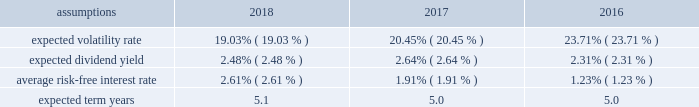Notes to the audited consolidated financial statements director stock compensation subplan eastman's 2018 director stock compensation subplan ( "directors' subplan" ) , a component of the 2017 omnibus plan , remains in effect until terminated by the board of directors or the earlier termination of the 2017 omnibus plan .
The directors' subplan provides for structured awards of restricted shares to non-employee members of the board of directors .
Restricted shares awarded under the directors' subplan are subject to the same terms and conditions of the 2017 omnibus plan .
The directors' subplan does not constitute a separate source of shares for grant of equity awards and all shares awarded are part of the 10 million shares authorized under the 2017 omnibus plan .
Shares of restricted stock are granted on the first day of a non- employee director's initial term of service and shares of restricted stock are granted each year to each non-employee director on the date of the annual meeting of stockholders .
It has been the company's practice to issue new shares rather than treasury shares for equity awards for compensation plans , including the 2017 omnibus plan and the directors' subplan , that require settlement by the issuance of common stock and to withhold or accept back shares awarded to cover the related income tax obligations of employee participants .
Shares of unrestricted common stock owned by non-employee directors are not eligible to be withheld or acquired to satisfy the withholding obligation related to their income taxes .
Shares of unrestricted common stock owned by specified senior management level employees are accepted by the company to pay the exercise price of stock options in accordance with the terms and conditions of their awards .
Compensation expense for 2018 , 2017 , and 2016 , total share-based compensation expense ( before tax ) of approximately $ 64 million , $ 52 million , and $ 36 million , respectively , was recognized in "selling , general and administrative expense" in the consolidated statements of earnings , comprehensive income and retained earnings for all share-based awards of which approximately $ 9 million , $ 8 million , and $ 7 million , respectively , related to stock options .
The compensation expense is recognized over the substantive vesting period , which may be a shorter time period than the stated vesting period for qualifying termination eligible employees as defined in the forms of award notice .
Approximately $ 3 million for 2018 , and $ 2 million for both 2017 and 2016 , of stock option compensation expense was recognized each year due to qualifying termination eligibility preceding the requisite vesting period .
Stock option awards options have been granted on an annual basis to non-employee directors under the directors' subplan and predecessor plans and by the compensation and management development committee of the board of directors under the 2017 omnibus plan and predecessor plans to employees .
Option awards have an exercise price equal to the closing price of the company's stock on the date of grant .
The term of options is 10 years with vesting periods that vary up to three years .
Vesting usually occurs ratably over the vesting period or at the end of the vesting period .
The company utilizes the black scholes merton option valuation model which relies on certain assumptions to estimate an option's fair value .
The weighted average assumptions used in the determination of fair value for stock options awarded in 2018 , 2017 , and 2016 are provided in the table below: .
The volatility rate of grants is derived from historical company common stock price volatility over the same time period as the expected term of each stock option award .
The volatility rate is derived by mathematical formula utilizing the weekly high closing stock price data over the expected term .
The expected dividend yield is calculated using the company's average of the last four quarterly dividend yields .
The average risk-free interest rate is derived from united states department of treasury published interest rates of daily yield curves for the same time period as the expected term. .
What was the sum of the approximate compensation expense recognized in millions? 
Computations: ((3 + 2) + 2)
Answer: 7.0. 